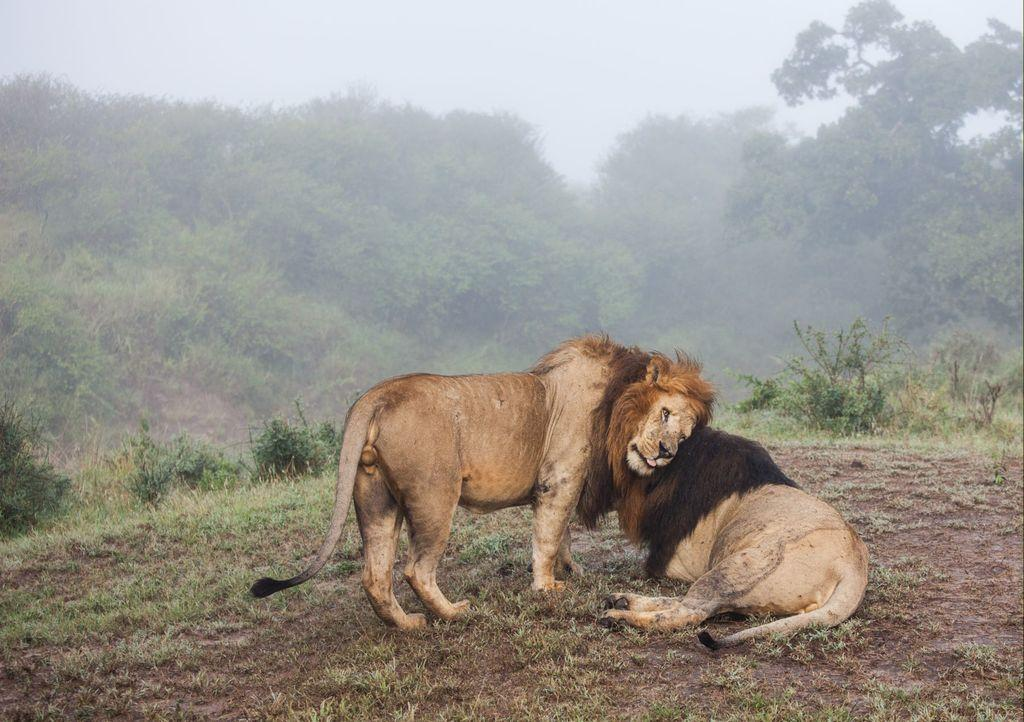How many lions are present in the image? There are two lions in the image. What are the positions of the lions in the image? One lion is standing, and the other lion is sitting on the grass. What can be seen in the background of the image? There are trees and the sky visible in the background of the image. Can you tell me what request the person in the image is making to the lions? There is no person present in the image, only two lions. How many bees can be seen buzzing around the lions in the image? There are no bees visible in the image; it features two lions and a grassy background. 